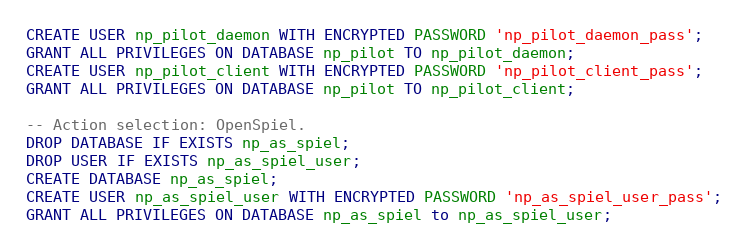<code> <loc_0><loc_0><loc_500><loc_500><_SQL_>CREATE USER np_pilot_daemon WITH ENCRYPTED PASSWORD 'np_pilot_daemon_pass';
GRANT ALL PRIVILEGES ON DATABASE np_pilot TO np_pilot_daemon;
CREATE USER np_pilot_client WITH ENCRYPTED PASSWORD 'np_pilot_client_pass';
GRANT ALL PRIVILEGES ON DATABASE np_pilot TO np_pilot_client;

-- Action selection: OpenSpiel.
DROP DATABASE IF EXISTS np_as_spiel;
DROP USER IF EXISTS np_as_spiel_user;
CREATE DATABASE np_as_spiel;
CREATE USER np_as_spiel_user WITH ENCRYPTED PASSWORD 'np_as_spiel_user_pass';
GRANT ALL PRIVILEGES ON DATABASE np_as_spiel to np_as_spiel_user;
</code> 